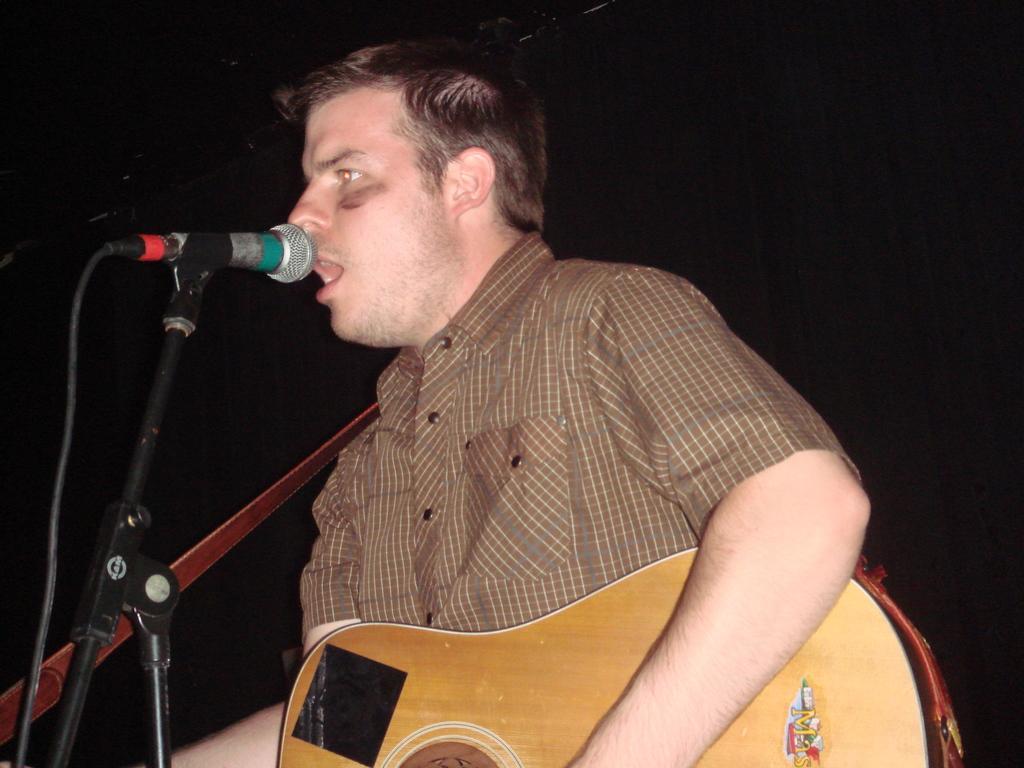Please provide a concise description of this image. Here we can see a person is sitting, and singing, and holding a guitar in his hands, and in front her is the microphone and stand. 